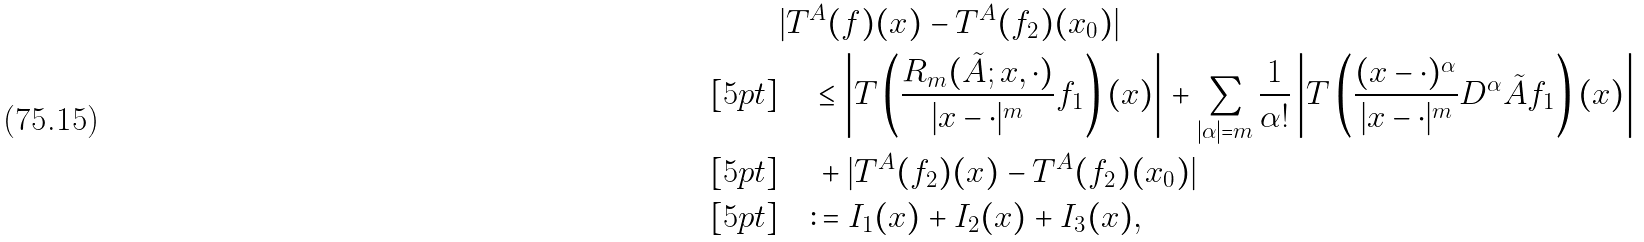<formula> <loc_0><loc_0><loc_500><loc_500>& | T ^ { A } ( f ) ( x ) - T ^ { A } ( f _ { 2 } ) ( x _ { 0 } ) | \\ [ 5 p t ] & \quad \leq \left | T \left ( \frac { R _ { m } ( \tilde { A } ; x , \cdot ) } { | x - \cdot | ^ { m } } f _ { 1 } \right ) ( x ) \right | + \sum _ { | \alpha | = m } \frac { 1 } { \alpha ! } \left | T \left ( \frac { ( x - \cdot ) ^ { \alpha } } { | x - \cdot | ^ { m } } D ^ { \alpha } \tilde { A } f _ { 1 } \right ) ( x ) \right | \\ [ 5 p t ] & \quad \, + | T ^ { A } ( f _ { 2 } ) ( x ) - T ^ { A } ( f _ { 2 } ) ( x _ { 0 } ) | \\ [ 5 p t ] & \quad \colon = I _ { 1 } ( x ) + I _ { 2 } ( x ) + I _ { 3 } ( x ) ,</formula> 